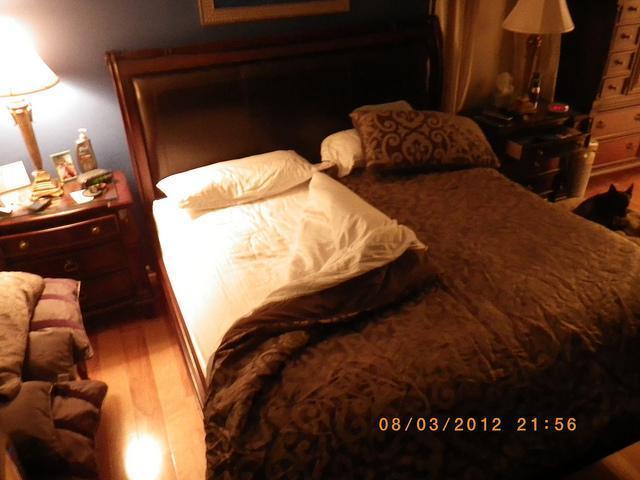How many lamps are visible?
Give a very brief answer. 2. How many people are in this scene?
Give a very brief answer. 0. 